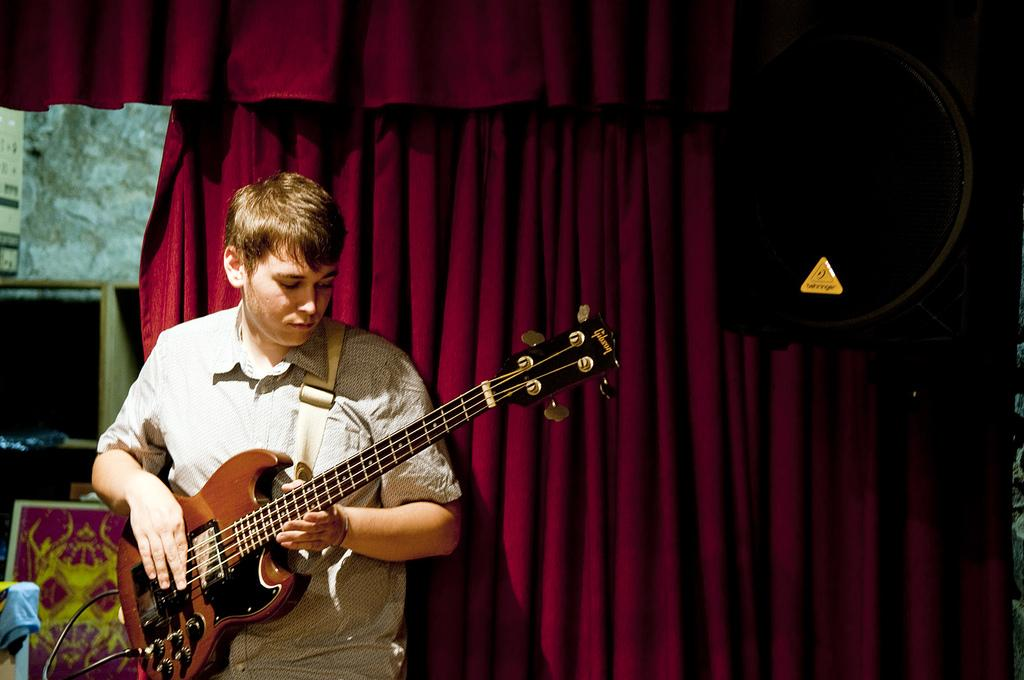Who is present in the image? There is a man in the image. What is the man holding in the image? The man is holding a guitar. Can you describe the background of the image? There is a red colored cloth in the background of the image. What type of protest is taking place in the image? There is no protest present in the image; it features a man holding a guitar. How many snakes can be seen in the image? There are no snakes present in the image. 